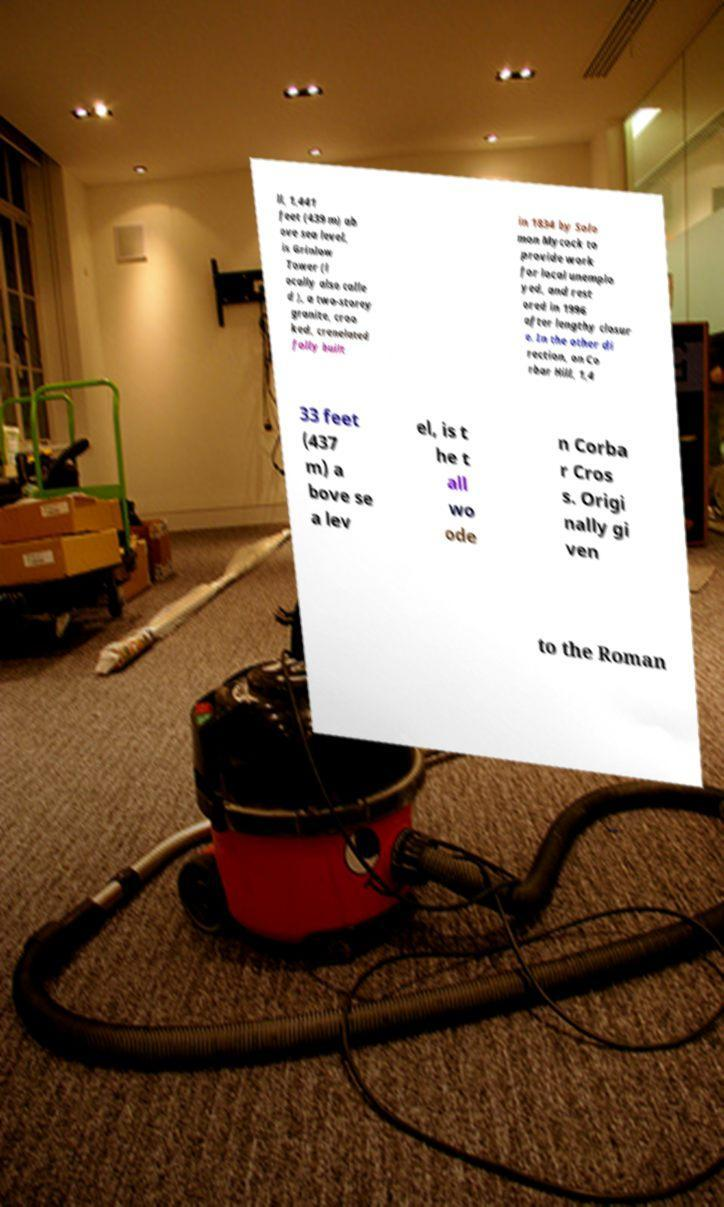Please read and relay the text visible in this image. What does it say? ll, 1,441 feet (439 m) ab ove sea level, is Grinlow Tower (l ocally also calle d ), a two-storey granite, croo ked, crenelated folly built in 1834 by Solo mon Mycock to provide work for local unemplo yed, and rest ored in 1996 after lengthy closur e. In the other di rection, on Co rbar Hill, 1,4 33 feet (437 m) a bove se a lev el, is t he t all wo ode n Corba r Cros s. Origi nally gi ven to the Roman 